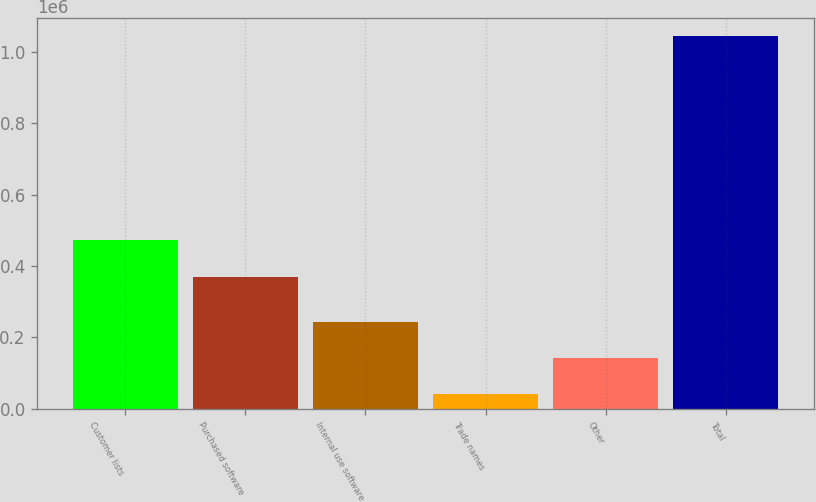Convert chart. <chart><loc_0><loc_0><loc_500><loc_500><bar_chart><fcel>Customer lists<fcel>Purchased software<fcel>Internal use software<fcel>Trade names<fcel>Other<fcel>Total<nl><fcel>472697<fcel>369728<fcel>241940<fcel>41224<fcel>141582<fcel>1.0448e+06<nl></chart> 